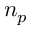<formula> <loc_0><loc_0><loc_500><loc_500>n _ { p }</formula> 